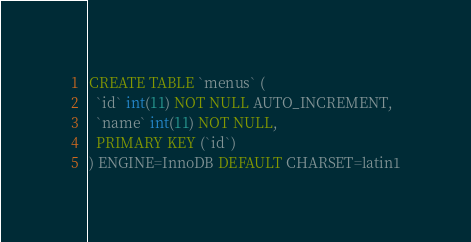<code> <loc_0><loc_0><loc_500><loc_500><_SQL_>CREATE TABLE `menus` (
  `id` int(11) NOT NULL AUTO_INCREMENT,
  `name` int(11) NOT NULL,
  PRIMARY KEY (`id`)
) ENGINE=InnoDB DEFAULT CHARSET=latin1</code> 